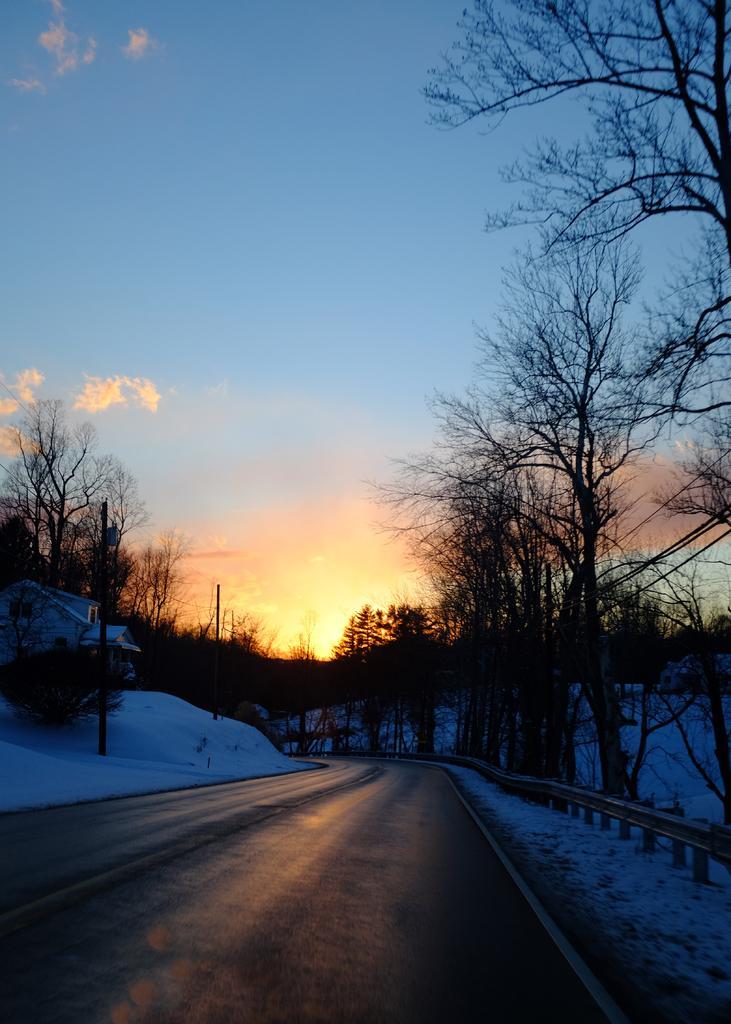Could you give a brief overview of what you see in this image? In this image there are trees and we can see a road. There is snow. On the left there is a shed. In the background there is sky. 